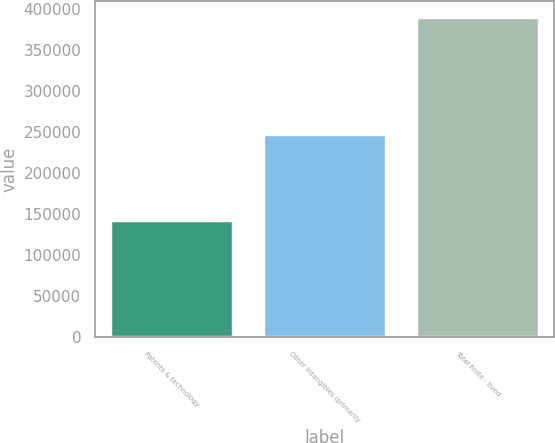Convert chart. <chart><loc_0><loc_0><loc_500><loc_500><bar_chart><fcel>Patents & technology<fcel>Other intangibles (primarily<fcel>Total finite - lived<nl><fcel>142850<fcel>247984<fcel>390834<nl></chart> 